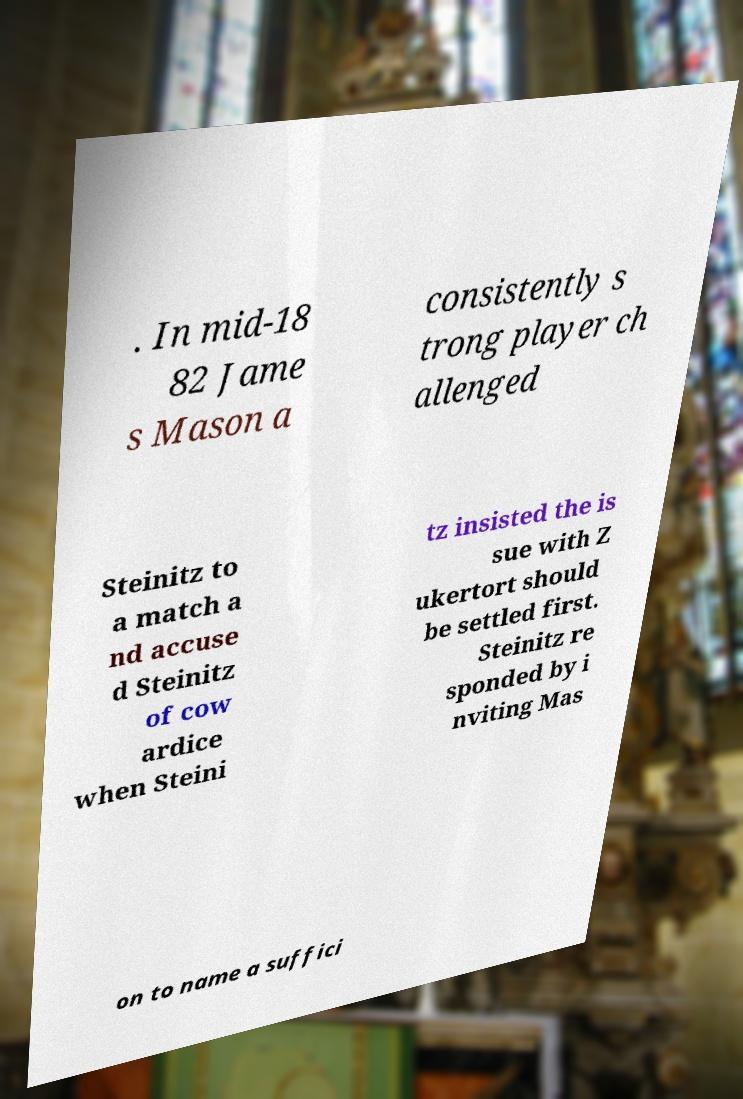I need the written content from this picture converted into text. Can you do that? . In mid-18 82 Jame s Mason a consistently s trong player ch allenged Steinitz to a match a nd accuse d Steinitz of cow ardice when Steini tz insisted the is sue with Z ukertort should be settled first. Steinitz re sponded by i nviting Mas on to name a suffici 